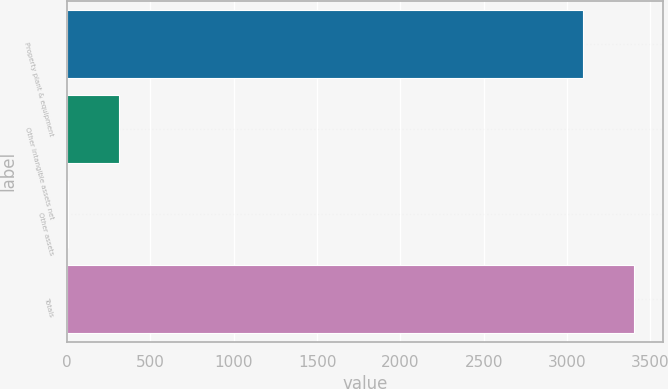Convert chart to OTSL. <chart><loc_0><loc_0><loc_500><loc_500><bar_chart><fcel>Property plant & equipment<fcel>Other intangible assets net<fcel>Other assets<fcel>Totals<nl><fcel>3095<fcel>311.8<fcel>2.56<fcel>3404.24<nl></chart> 